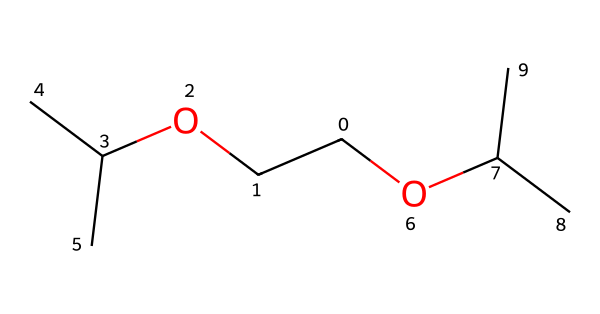What is the total number of carbon atoms in the structure? The SMILES representation has 8 carbon atoms. Each 'C' represents a carbon atom, and counting them in the structure gives 8.
Answer: 8 How many hydroxyl (OH) groups are present in this molecule? The given SMILES structure does not include any hydroxyl (OH) groups. There are no -OH functional groups indicated in the representation.
Answer: 0 What type of bonding connects the carbon atoms in this structure? The carbon atoms are connected by single bonds, as represented by the absence of double or triple bond symbols in the SMILES notation.
Answer: single What could be a potential application of this organic compound in biocompatible hydrogels? Given its structure, this compound could be used in hydrogels due to its possible flexibility and ability to form networks, which is beneficial for biosensing applications.
Answer: biosensing What is the branching pattern of the carbon chain? The carbon chain exhibits branching, as seen from the structure where some carbon atoms are connected to more than two other carbon atoms, indicating a branched alkane.
Answer: branched Does this molecule contain any functional groups that would enhance its biocompatibility? The structure does not explicitly show common functional groups like -OH or -NH2 that typically enhance biocompatibility, suggesting it may have limited inherent biocompatibility.
Answer: limited Which carbon atoms are part of the alkoxy functional group? The alkoxy functional group is characterized by the presence of an ether linkage; in this structure, the terminal carbon connected to -OC(C)C indicates the alkoxy part.
Answer: terminal carbon 